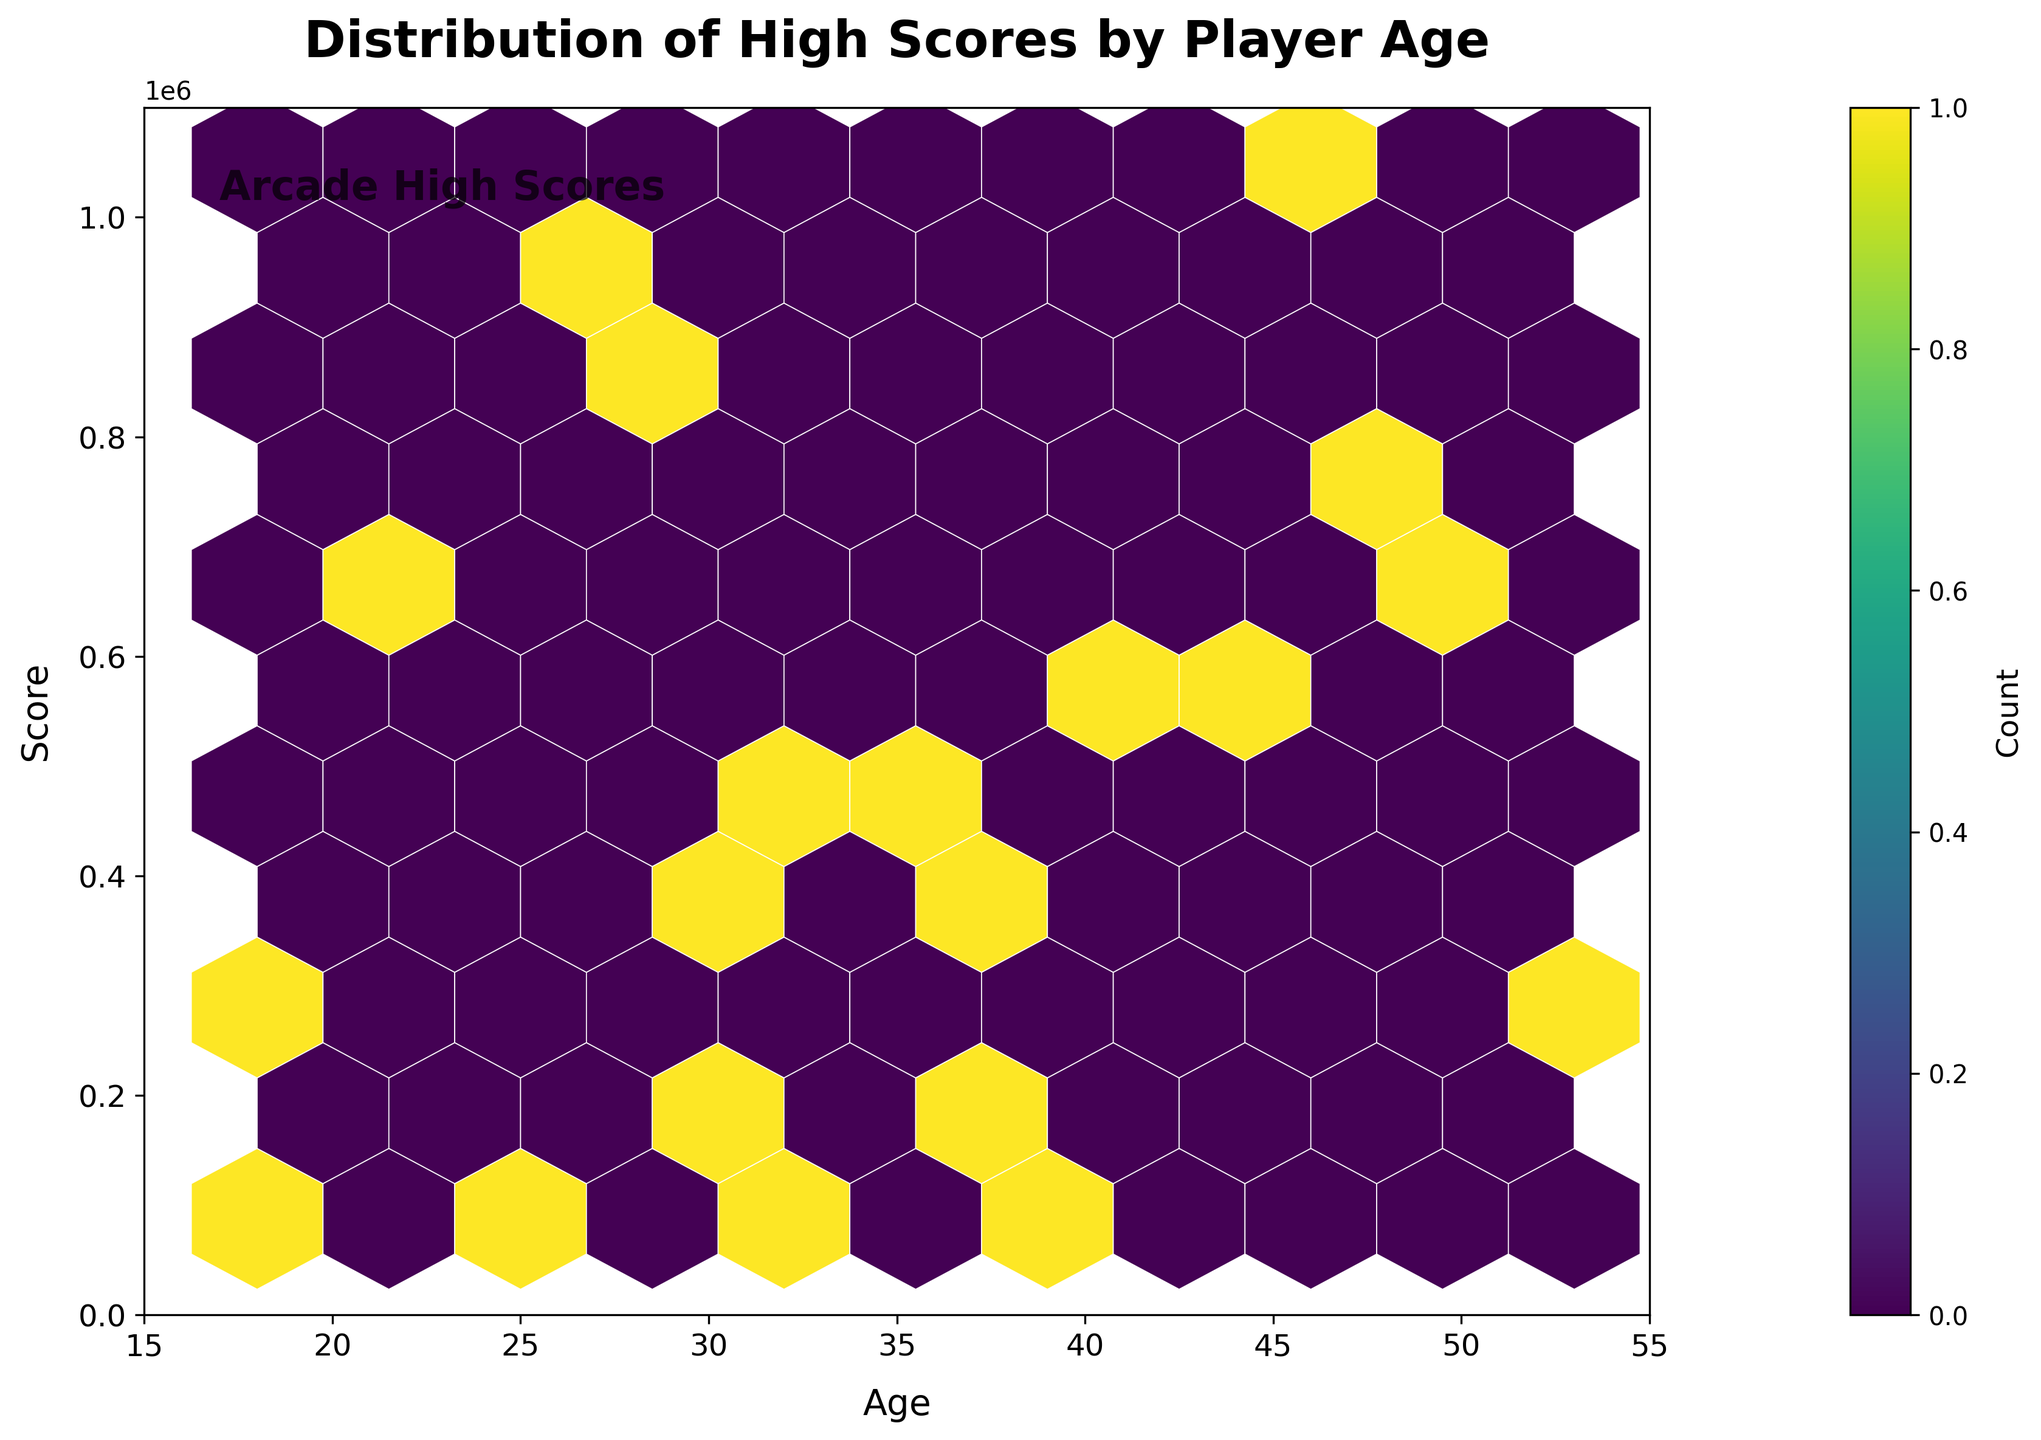What does the title of the plot say? The title is located at the top of the plot, often in a larger and bolder font. This helps to quickly convey the main subject of the plot.
Answer: Distribution of High Scores by Player Age What is shown on the x-axis of the plot? The x-axis label is positioned horizontally at the bottom of the plot and is generally annotated in text to indicate the variable it represents.
Answer: Age What does the color legend (or color bar) represent? The color bar is positioned alongside the plot and includes a range of colors that indicate the count of data points within each hexbin. The label on the color bar provides further context.
Answer: Count What age range is covered on the x-axis? The x-axis has two endpoints that provide the range of values covered. These can be seen at the far left and far right of the axis.
Answer: 15 to 55 What is the highest score range shown on the y-axis? The y-axis has endpoints at the bottom and the top, showing the range of scores covered by the plot. The maximum value at the top of this axis represents the highest score range.
Answer: 0 to 1,100,000 How many hexagonal bins have the highest count based on the color bar? The colors on the hexagons change from light to dark, indicating the number of data points in each bin. The darkest color corresponds to the highest counts as shown in the color bar. Counting these darkest bins gives the answer.
Answer: 1 Which age group shows the densest concentration of high scores? By observing the plot and noting where the hexagons are most densely packed and darkest, one can determine the age group with the most players scoring high.
Answer: Around 30-35 What is the maximum score achieved below the age of 25? Looking towards the lower part of the age range (15-25) on the x-axis and tracking the highest point on the y-axis within this range can answer the question.
Answer: 875,000 Which player age group has the highest variation in scores? Variation is observed by noting the spread of hexagons along the y-axis for different age groups. The age group with the widest distribution of hexagons vertically represents the highest variation in scores.
Answer: 30-40 Is there any correlation between age and score? By examining the overall spread of hexagons along both the x-axis and y-axis, one can infer if there is a trend where scores increase or decrease with age, or if they are randomly distributed.
Answer: No clear correlation 